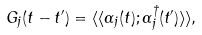<formula> <loc_0><loc_0><loc_500><loc_500>G _ { j } ( t - t ^ { \prime } ) = \langle \langle \alpha _ { j } ( t ) ; \alpha ^ { \dagger } _ { j } ( t ^ { \prime } ) \rangle \rangle ,</formula> 